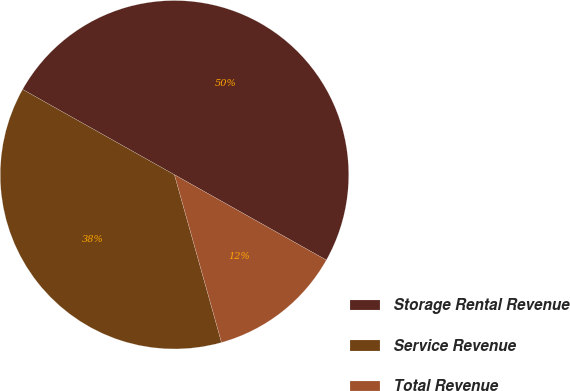<chart> <loc_0><loc_0><loc_500><loc_500><pie_chart><fcel>Storage Rental Revenue<fcel>Service Revenue<fcel>Total Revenue<nl><fcel>50.0%<fcel>37.5%<fcel>12.5%<nl></chart> 